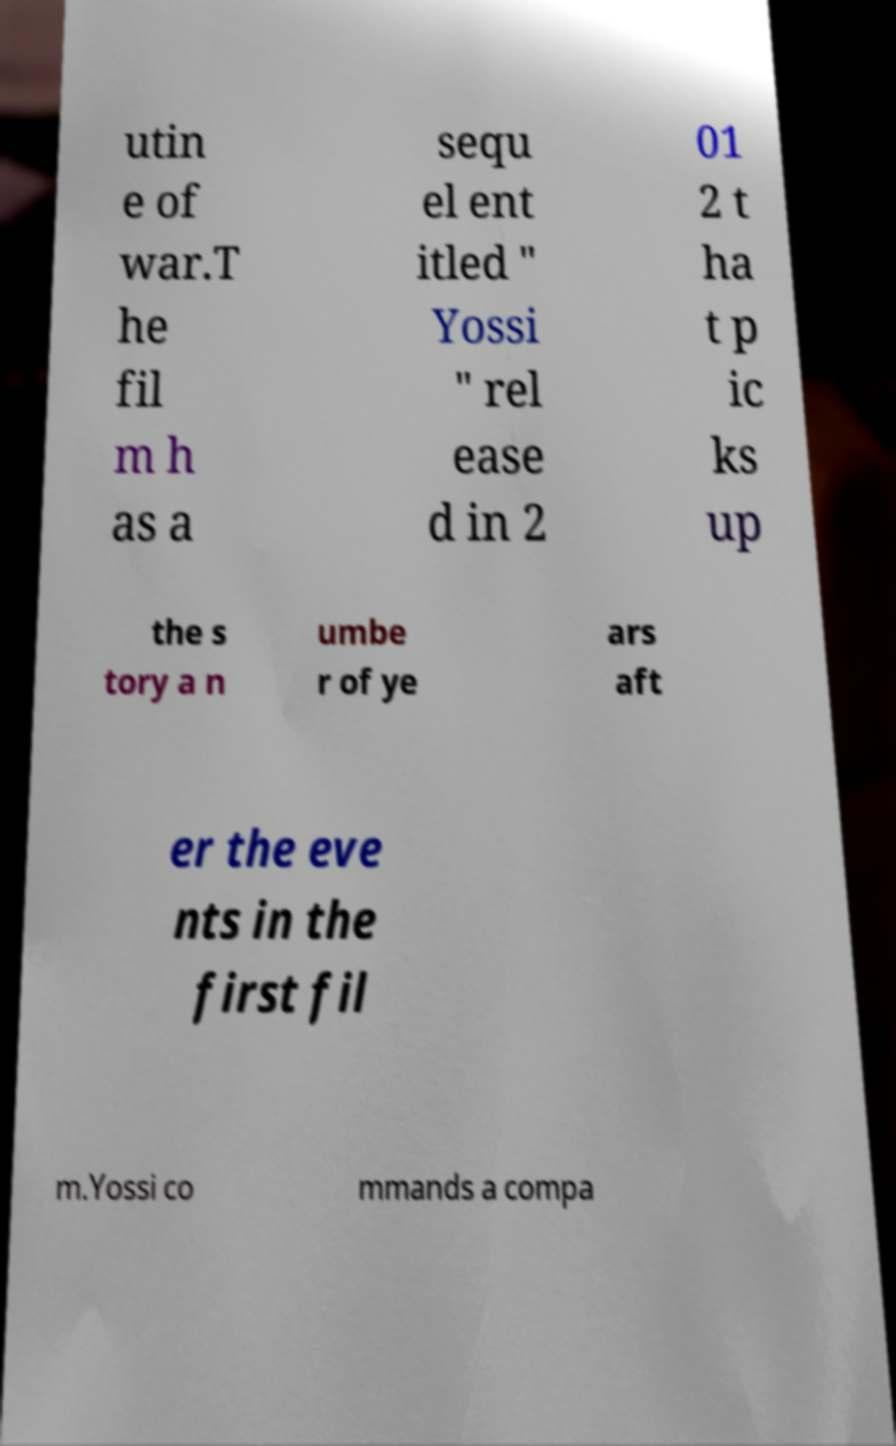Please identify and transcribe the text found in this image. utin e of war.T he fil m h as a sequ el ent itled " Yossi " rel ease d in 2 01 2 t ha t p ic ks up the s tory a n umbe r of ye ars aft er the eve nts in the first fil m.Yossi co mmands a compa 